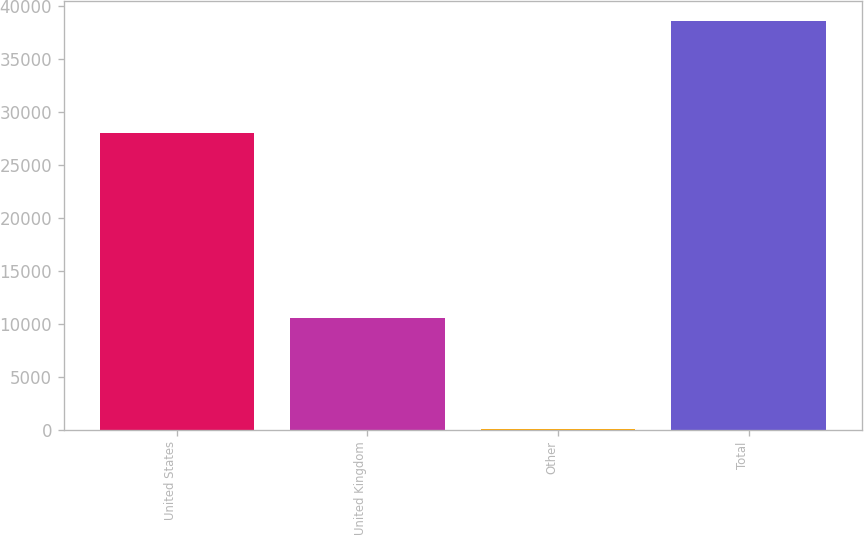<chart> <loc_0><loc_0><loc_500><loc_500><bar_chart><fcel>United States<fcel>United Kingdom<fcel>Other<fcel>Total<nl><fcel>27990<fcel>10532<fcel>26<fcel>38548<nl></chart> 